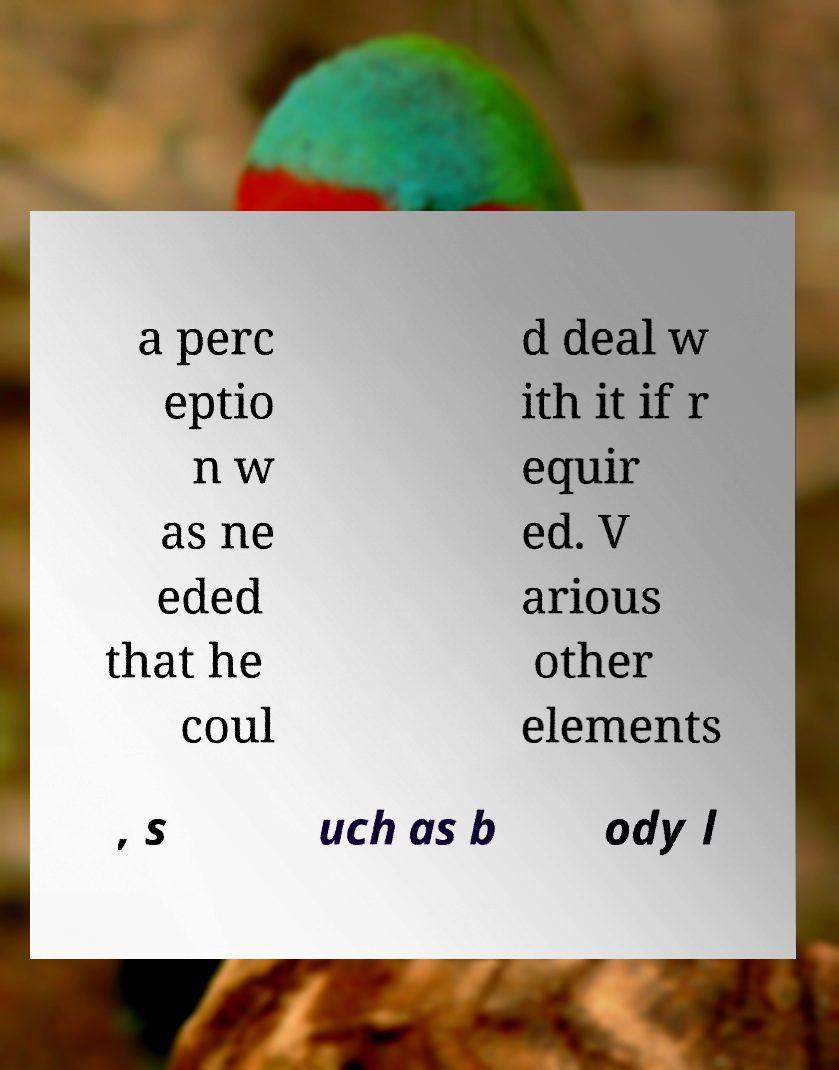Could you assist in decoding the text presented in this image and type it out clearly? a perc eptio n w as ne eded that he coul d deal w ith it if r equir ed. V arious other elements , s uch as b ody l 